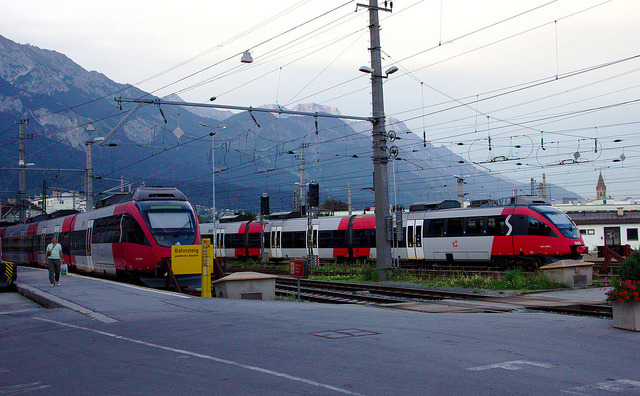What type of trains are shown in the image? The image displays modern passenger trains, identifiable by their sleek design and the livery indicating they are part of a regional or city rail service. Are the trains stationary or moving? The trains appear to be stationary, as suggested by the lack of motion blur and the presence of multiple trains in a converging fashion, which is typical of a train station. 